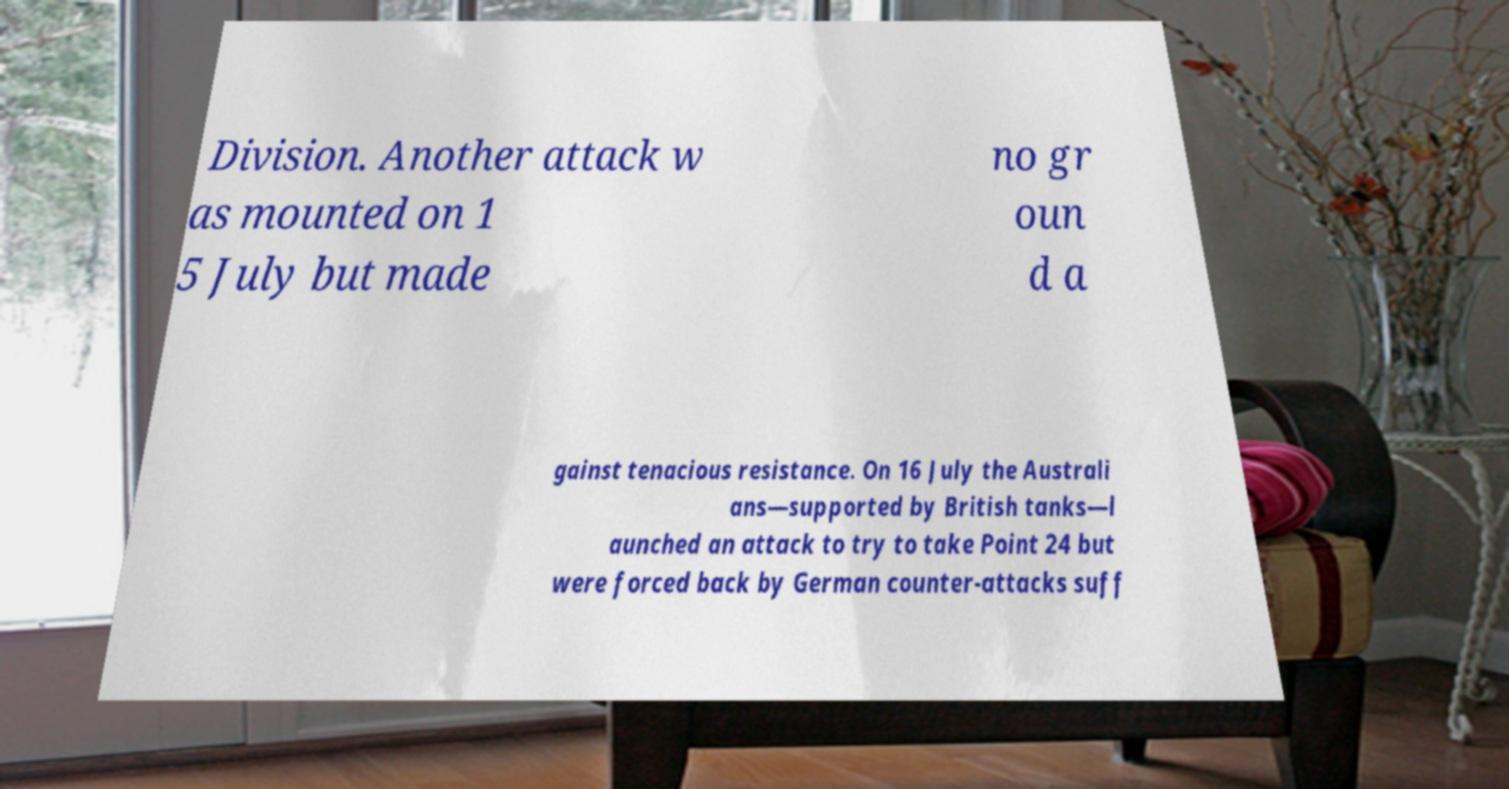I need the written content from this picture converted into text. Can you do that? Division. Another attack w as mounted on 1 5 July but made no gr oun d a gainst tenacious resistance. On 16 July the Australi ans—supported by British tanks—l aunched an attack to try to take Point 24 but were forced back by German counter-attacks suff 